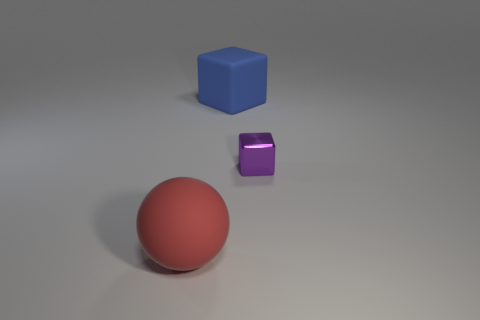Is there any other thing that has the same material as the purple object?
Offer a terse response. No. There is a rubber thing that is to the right of the red matte ball; does it have the same shape as the thing that is in front of the tiny cube?
Offer a very short reply. No. How many big objects are either red rubber objects or matte things?
Provide a succinct answer. 2. The other thing that is the same material as the red object is what shape?
Give a very brief answer. Cube. Do the purple thing and the blue matte thing have the same shape?
Provide a short and direct response. Yes. The shiny cube has what color?
Offer a very short reply. Purple. How many things are big green rubber spheres or red rubber things?
Offer a terse response. 1. Is the number of blue rubber things right of the big blue block less than the number of large gray cubes?
Keep it short and to the point. No. Is the number of large objects that are in front of the large ball greater than the number of metal things in front of the tiny purple thing?
Provide a short and direct response. No. Is there any other thing of the same color as the tiny thing?
Your answer should be compact. No. 